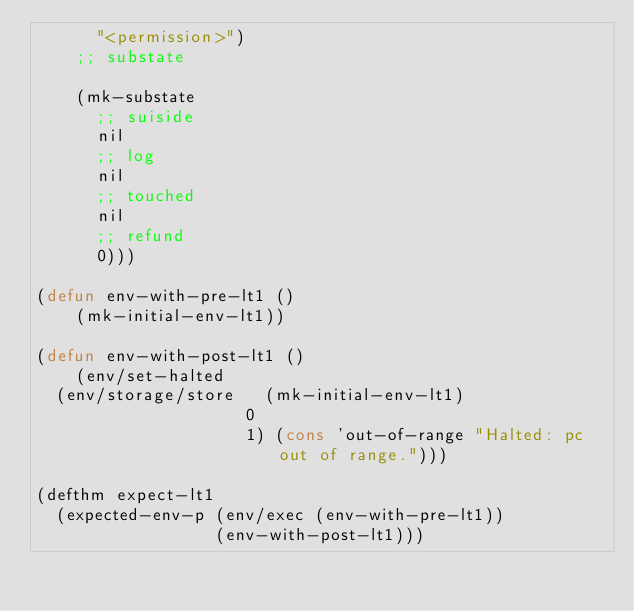<code> <loc_0><loc_0><loc_500><loc_500><_Lisp_>      "<permission>")
    ;; substate
  
    (mk-substate
      ;; suiside
      nil
      ;; log
      nil
      ;; touched
      nil
      ;; refund
      0)))

(defun env-with-pre-lt1 ()
    (mk-initial-env-lt1))

(defun env-with-post-lt1 ()
    (env/set-halted 
  (env/storage/store   (mk-initial-env-lt1)
                     0
                     1) (cons 'out-of-range "Halted: pc out of range.")))

(defthm expect-lt1
  (expected-env-p (env/exec (env-with-pre-lt1))
                  (env-with-post-lt1)))</code> 